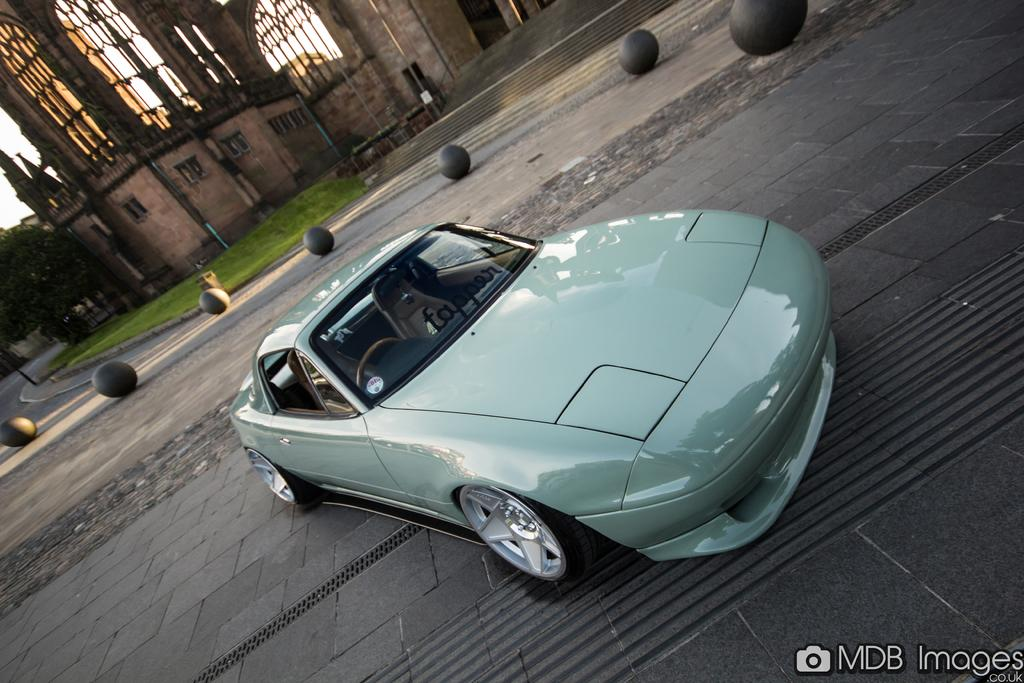What is the main subject of the image? The main subject of the image is a car on a pathway. What other objects can be seen in the image? There are balls, a dustbin, a tree, and a building with windows in the image. Can you describe the building in the image? The building has stairs and poles, and there is a board on the building. What type of butter is being used to smash the balls in the image? There is no butter or smashing of balls present in the image. 